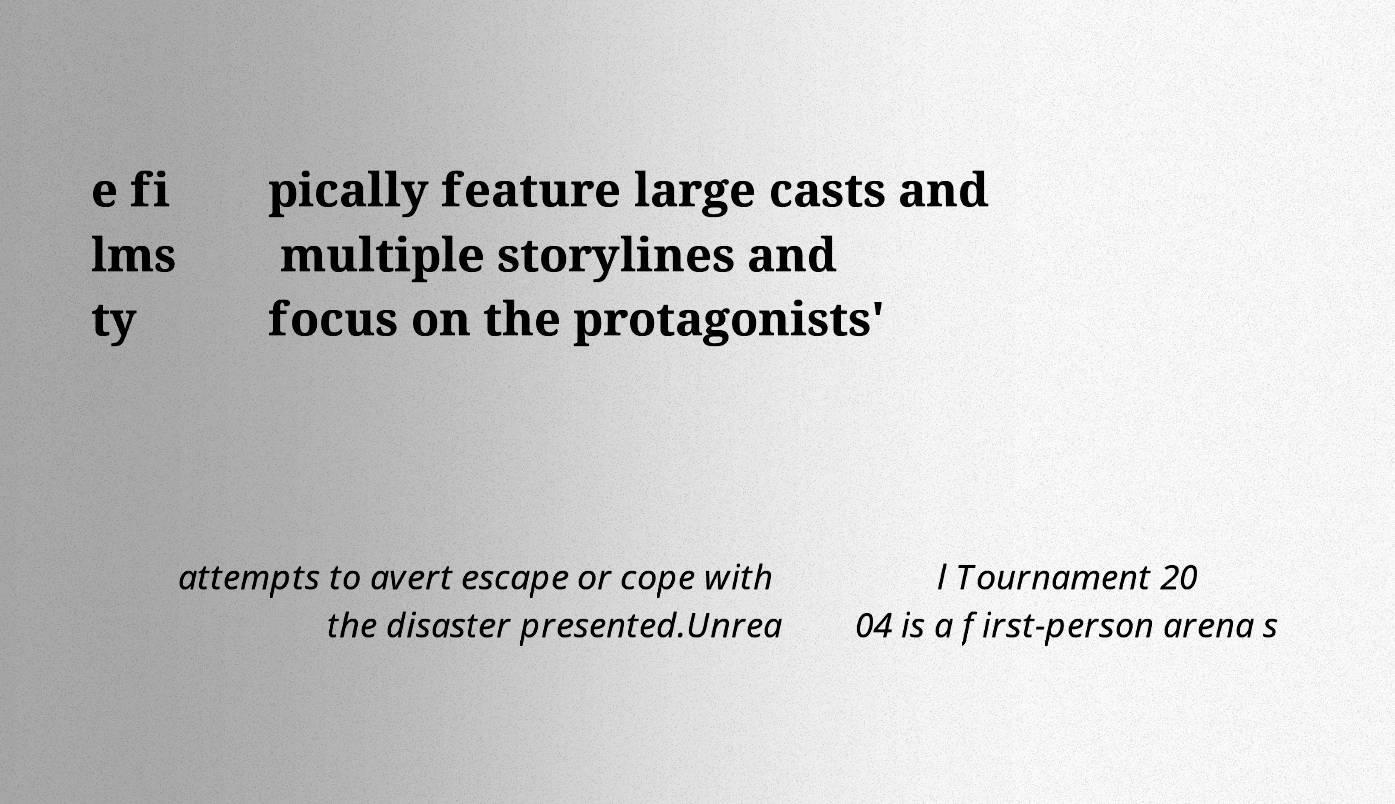I need the written content from this picture converted into text. Can you do that? e fi lms ty pically feature large casts and multiple storylines and focus on the protagonists' attempts to avert escape or cope with the disaster presented.Unrea l Tournament 20 04 is a first-person arena s 